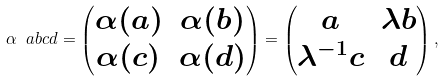Convert formula to latex. <formula><loc_0><loc_0><loc_500><loc_500>\alpha \ a b c d = \begin{pmatrix} \alpha ( a ) & \alpha ( b ) \\ \alpha ( c ) & \alpha ( d ) \end{pmatrix} = \begin{pmatrix} a & \lambda b \\ \lambda ^ { - 1 } c & d \end{pmatrix} ,</formula> 